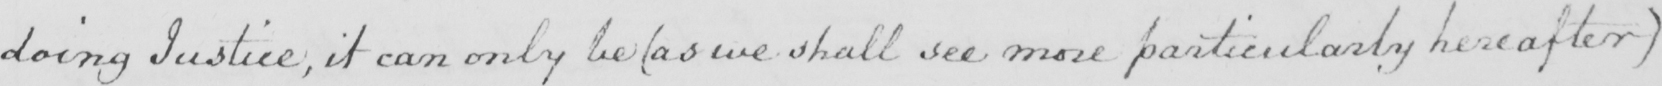Can you tell me what this handwritten text says? doing Justice , it can only be  ( as we shall see more particularly hereafter ) 